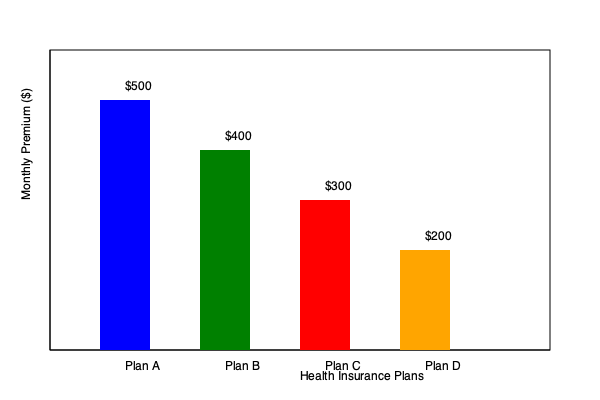As a startup founder creating a benefits package for your first employees, you're comparing different health insurance plans. Based on the bar graph showing monthly premiums for Plans A, B, C, and D, which plan would be most cost-effective for employees who rarely need medical care and are looking to minimize their monthly expenses? To determine the most cost-effective plan for employees who rarely need medical care and want to minimize monthly expenses, we need to analyze the monthly premiums shown in the bar graph:

1. Identify the monthly premiums for each plan:
   - Plan A: $500
   - Plan B: $400
   - Plan C: $300
   - Plan D: $200

2. Consider the employee profile:
   - They rarely need medical care
   - They want to minimize monthly expenses

3. Analyze the options:
   - Since the employees rarely need medical care, we can assume they don't require extensive coverage
   - The primary factor for these employees would be the lowest monthly premium

4. Compare the premiums:
   - Plan D has the lowest monthly premium at $200
   - This is significantly lower than the other options

5. Consider the startup context:
   - As a startup, offering a lower-cost option can be beneficial for both the company and employees
   - It allows for providing health coverage while managing expenses

6. Conclusion:
   - Plan D would be the most cost-effective for employees who rarely need medical care and want to minimize monthly expenses

It's important to note that while this plan is most cost-effective for the given scenario, it may not provide the most comprehensive coverage. As a startup founder, you should also consider offering multiple options to cater to different employee needs.
Answer: Plan D 